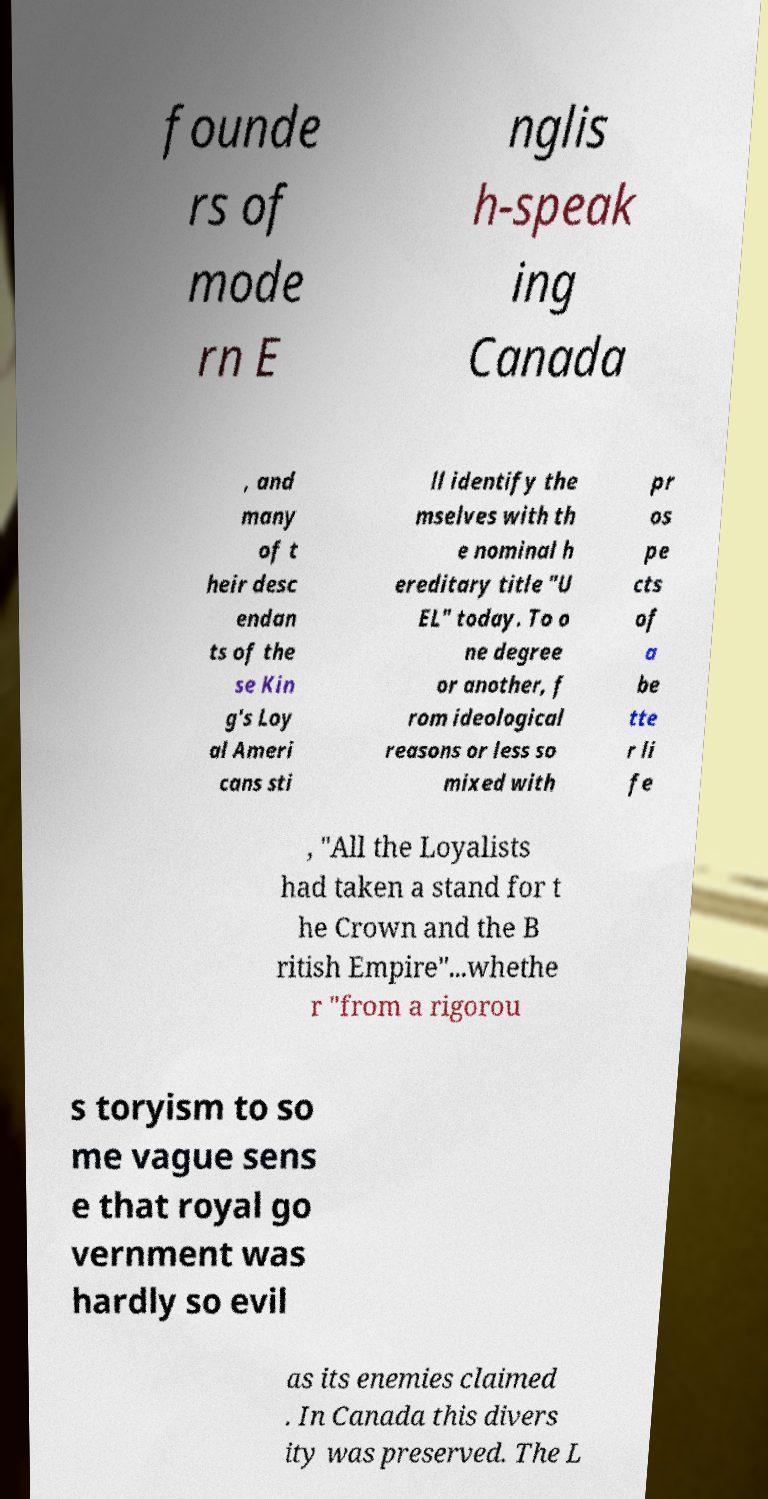Can you accurately transcribe the text from the provided image for me? founde rs of mode rn E nglis h-speak ing Canada , and many of t heir desc endan ts of the se Kin g's Loy al Ameri cans sti ll identify the mselves with th e nominal h ereditary title "U EL" today. To o ne degree or another, f rom ideological reasons or less so mixed with pr os pe cts of a be tte r li fe , "All the Loyalists had taken a stand for t he Crown and the B ritish Empire"...whethe r "from a rigorou s toryism to so me vague sens e that royal go vernment was hardly so evil as its enemies claimed . In Canada this divers ity was preserved. The L 